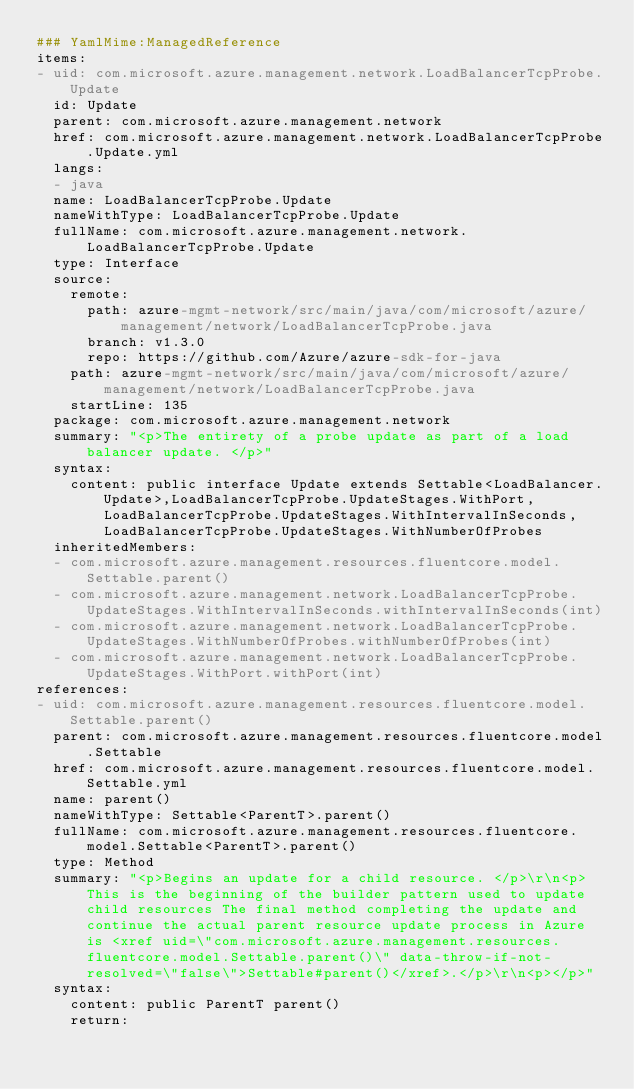<code> <loc_0><loc_0><loc_500><loc_500><_YAML_>### YamlMime:ManagedReference
items:
- uid: com.microsoft.azure.management.network.LoadBalancerTcpProbe.Update
  id: Update
  parent: com.microsoft.azure.management.network
  href: com.microsoft.azure.management.network.LoadBalancerTcpProbe.Update.yml
  langs:
  - java
  name: LoadBalancerTcpProbe.Update
  nameWithType: LoadBalancerTcpProbe.Update
  fullName: com.microsoft.azure.management.network.LoadBalancerTcpProbe.Update
  type: Interface
  source:
    remote:
      path: azure-mgmt-network/src/main/java/com/microsoft/azure/management/network/LoadBalancerTcpProbe.java
      branch: v1.3.0
      repo: https://github.com/Azure/azure-sdk-for-java
    path: azure-mgmt-network/src/main/java/com/microsoft/azure/management/network/LoadBalancerTcpProbe.java
    startLine: 135
  package: com.microsoft.azure.management.network
  summary: "<p>The entirety of a probe update as part of a load balancer update. </p>"
  syntax:
    content: public interface Update extends Settable<LoadBalancer.Update>,LoadBalancerTcpProbe.UpdateStages.WithPort,LoadBalancerTcpProbe.UpdateStages.WithIntervalInSeconds,LoadBalancerTcpProbe.UpdateStages.WithNumberOfProbes
  inheritedMembers:
  - com.microsoft.azure.management.resources.fluentcore.model.Settable.parent()
  - com.microsoft.azure.management.network.LoadBalancerTcpProbe.UpdateStages.WithIntervalInSeconds.withIntervalInSeconds(int)
  - com.microsoft.azure.management.network.LoadBalancerTcpProbe.UpdateStages.WithNumberOfProbes.withNumberOfProbes(int)
  - com.microsoft.azure.management.network.LoadBalancerTcpProbe.UpdateStages.WithPort.withPort(int)
references:
- uid: com.microsoft.azure.management.resources.fluentcore.model.Settable.parent()
  parent: com.microsoft.azure.management.resources.fluentcore.model.Settable
  href: com.microsoft.azure.management.resources.fluentcore.model.Settable.yml
  name: parent()
  nameWithType: Settable<ParentT>.parent()
  fullName: com.microsoft.azure.management.resources.fluentcore.model.Settable<ParentT>.parent()
  type: Method
  summary: "<p>Begins an update for a child resource. </p>\r\n<p>This is the beginning of the builder pattern used to update child resources The final method completing the update and continue the actual parent resource update process in Azure is <xref uid=\"com.microsoft.azure.management.resources.fluentcore.model.Settable.parent()\" data-throw-if-not-resolved=\"false\">Settable#parent()</xref>.</p>\r\n<p></p>"
  syntax:
    content: public ParentT parent()
    return:</code> 